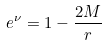<formula> <loc_0><loc_0><loc_500><loc_500>e ^ { \nu } = 1 - \frac { 2 M } { r }</formula> 